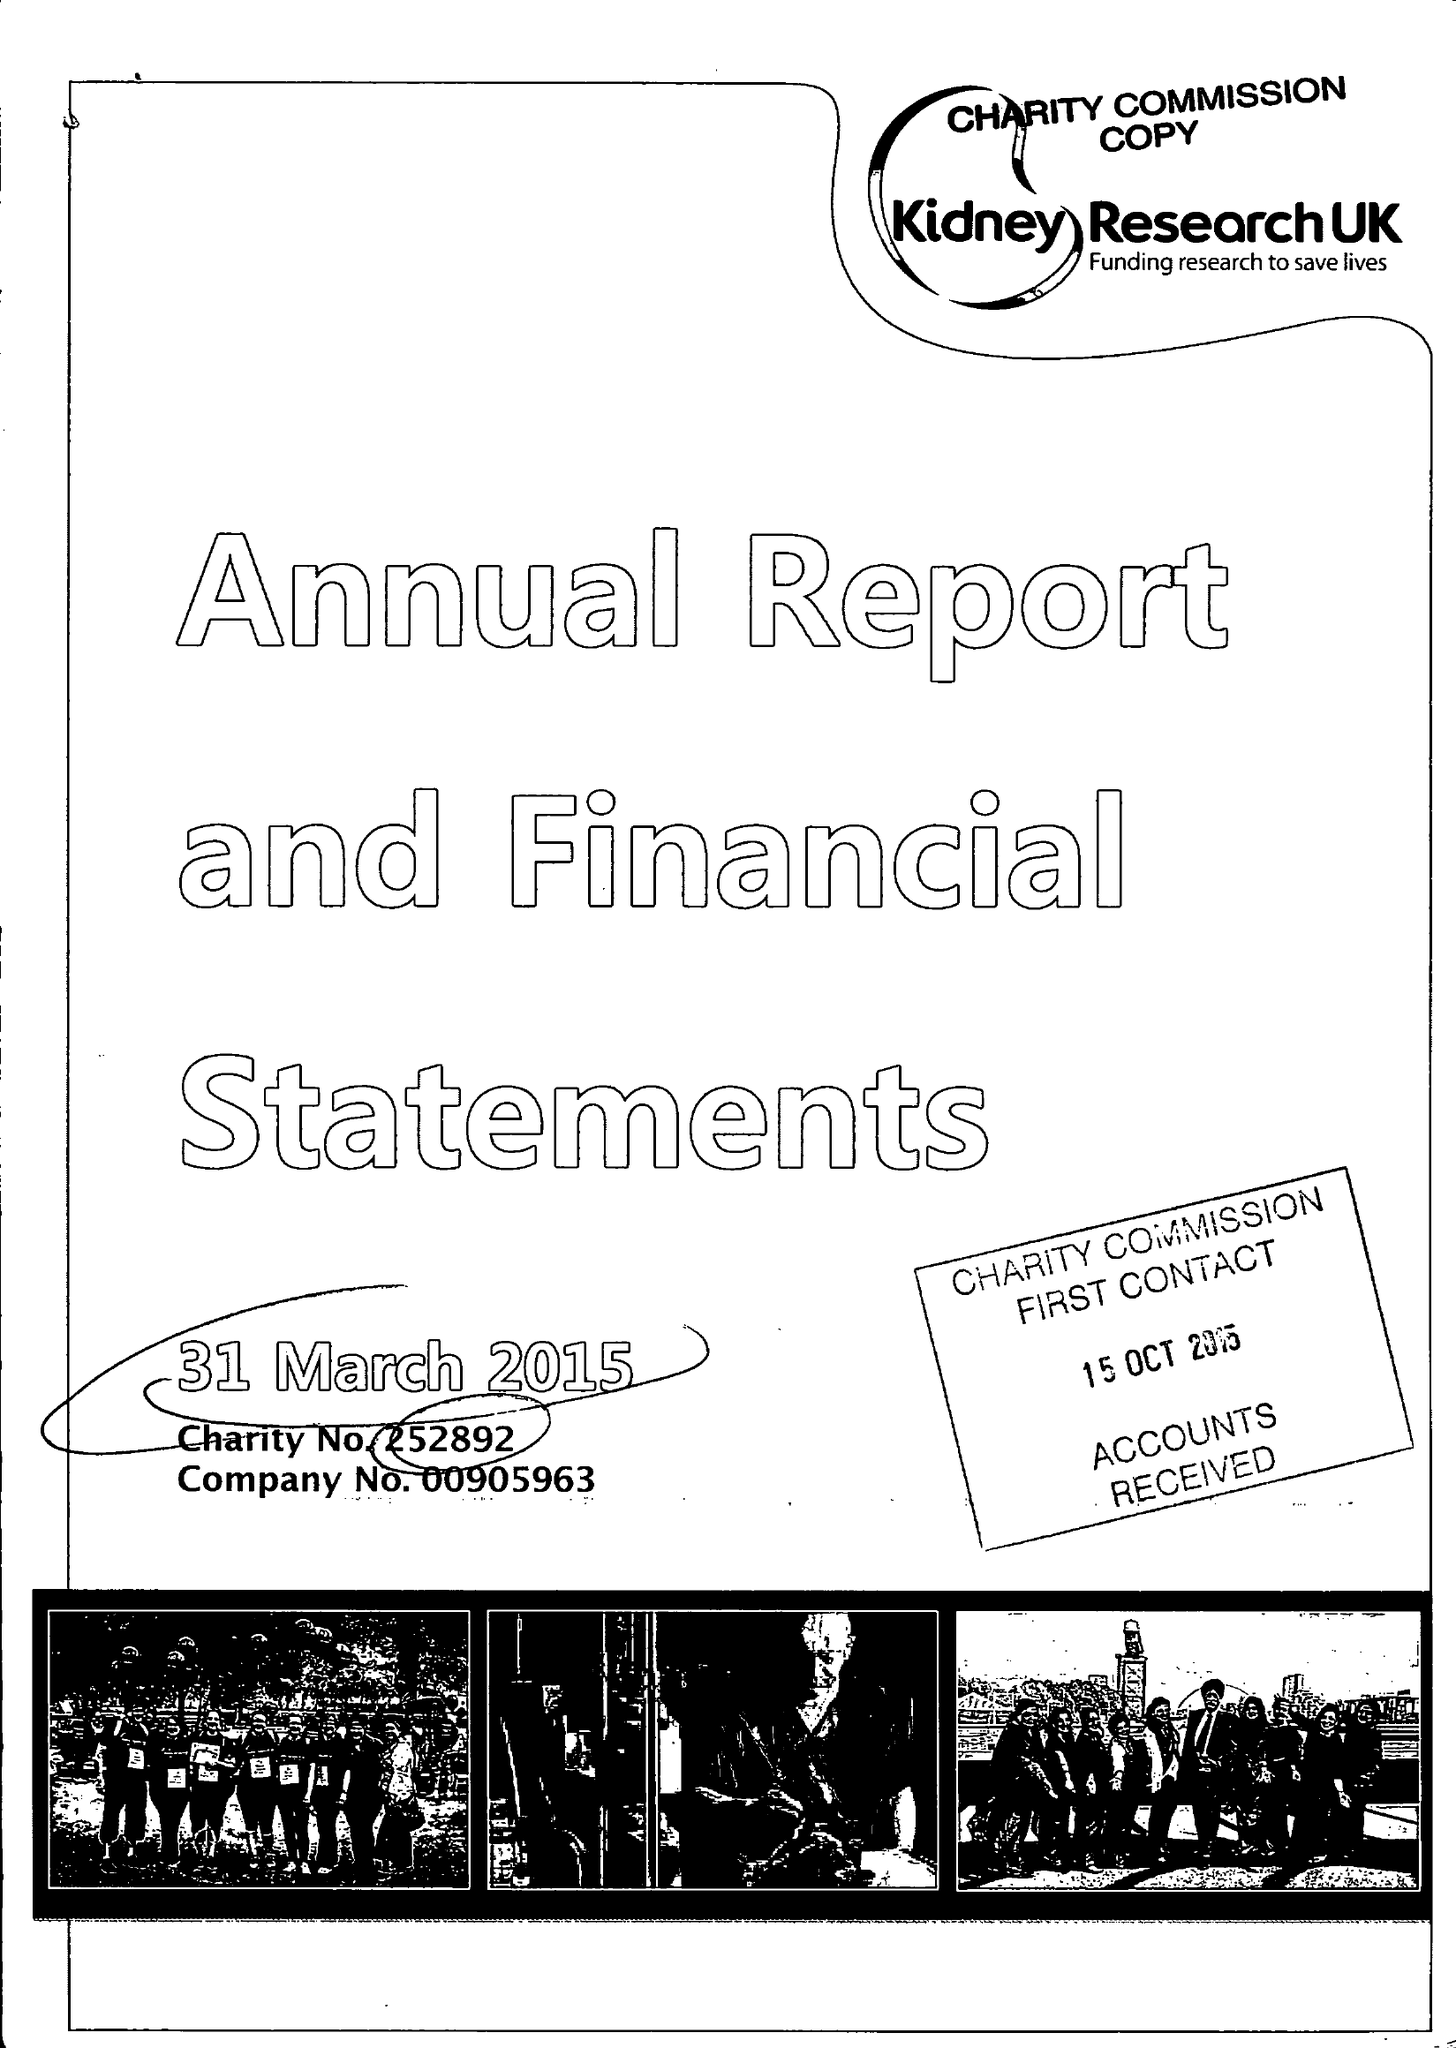What is the value for the report_date?
Answer the question using a single word or phrase. 2015-03-31 